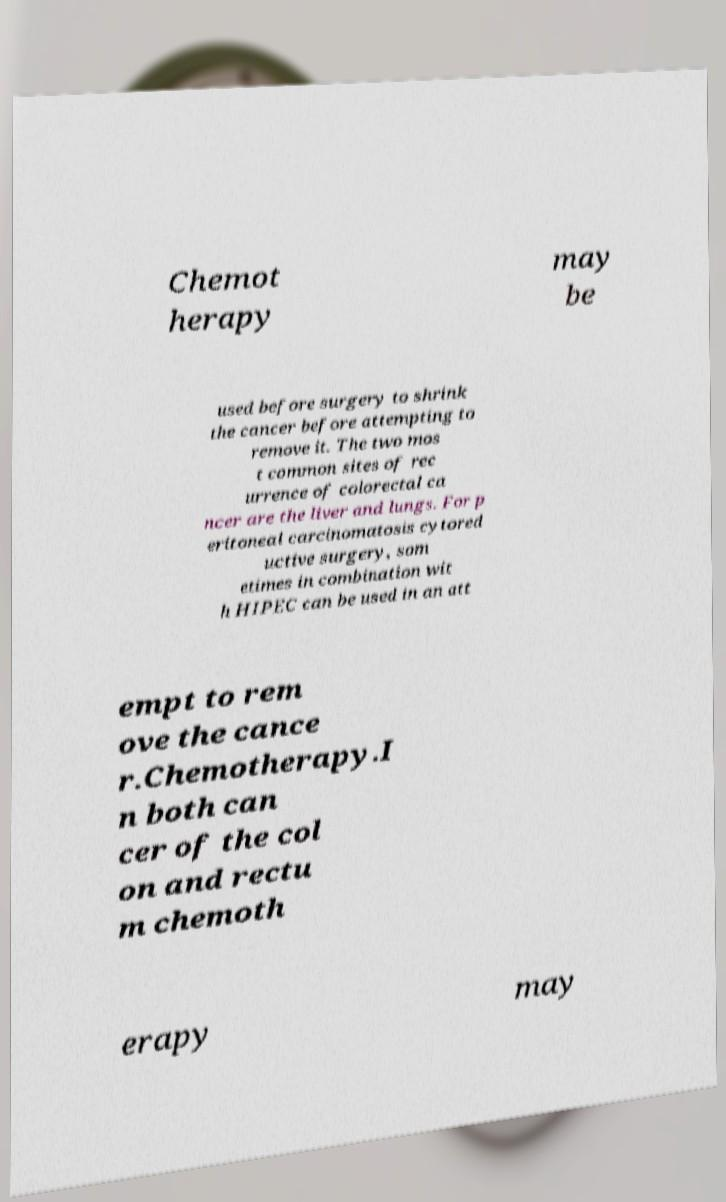What messages or text are displayed in this image? I need them in a readable, typed format. Chemot herapy may be used before surgery to shrink the cancer before attempting to remove it. The two mos t common sites of rec urrence of colorectal ca ncer are the liver and lungs. For p eritoneal carcinomatosis cytored uctive surgery, som etimes in combination wit h HIPEC can be used in an att empt to rem ove the cance r.Chemotherapy.I n both can cer of the col on and rectu m chemoth erapy may 